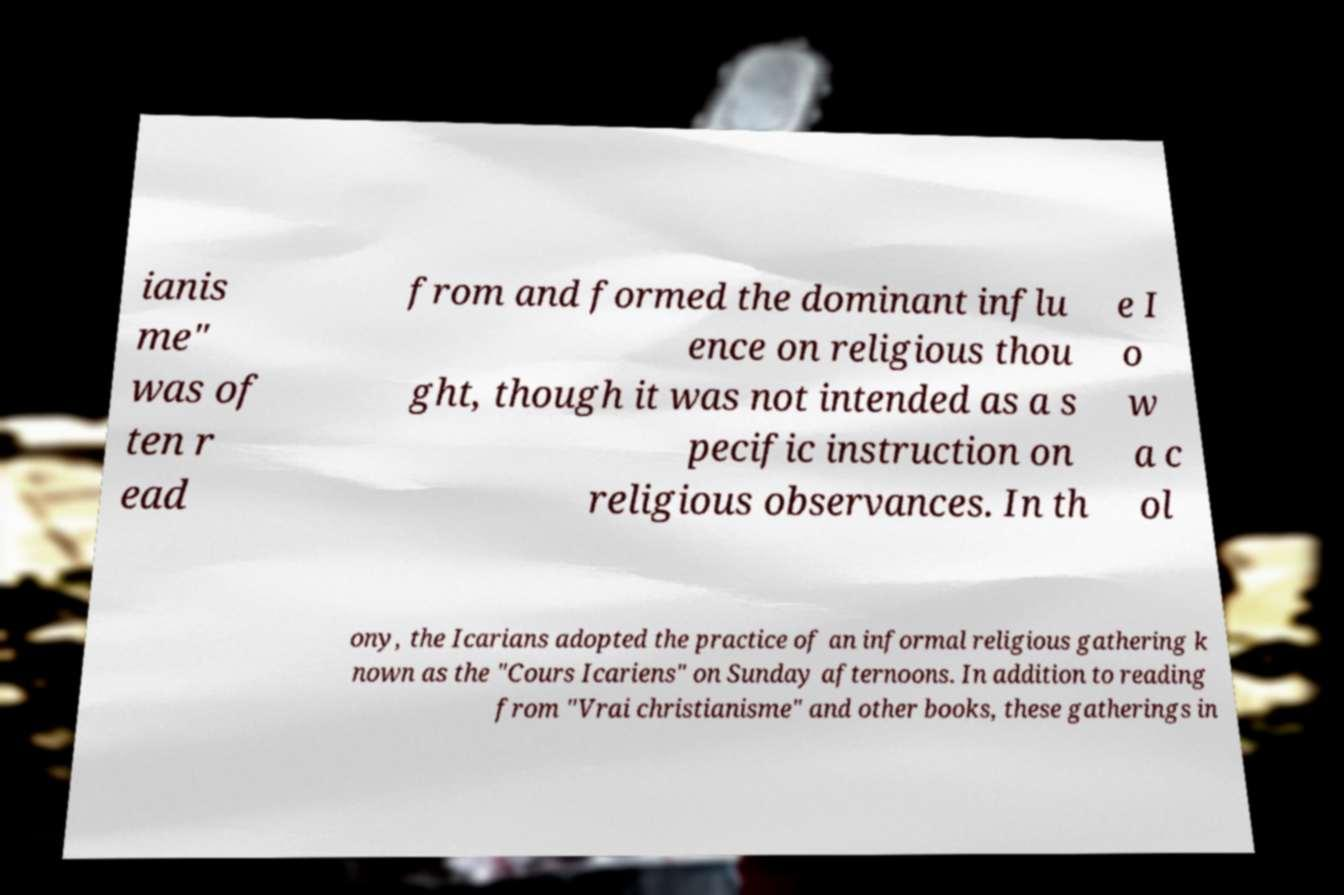Please identify and transcribe the text found in this image. ianis me" was of ten r ead from and formed the dominant influ ence on religious thou ght, though it was not intended as a s pecific instruction on religious observances. In th e I o w a c ol ony, the Icarians adopted the practice of an informal religious gathering k nown as the "Cours Icariens" on Sunday afternoons. In addition to reading from "Vrai christianisme" and other books, these gatherings in 